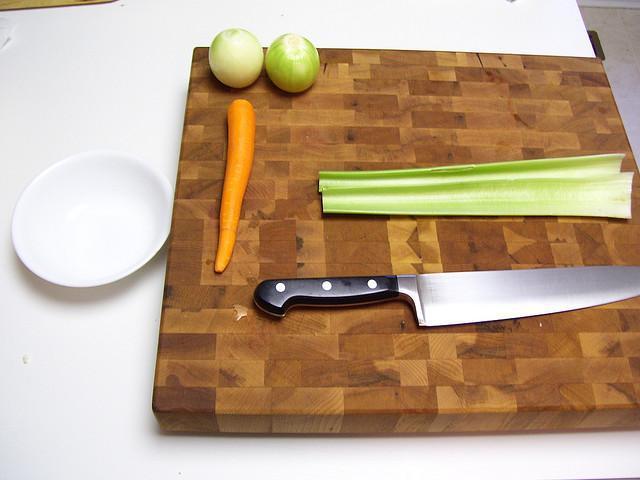How many stalks of celery are there?
Give a very brief answer. 2. How many carrots are there?
Give a very brief answer. 1. How many onions?
Give a very brief answer. 2. 